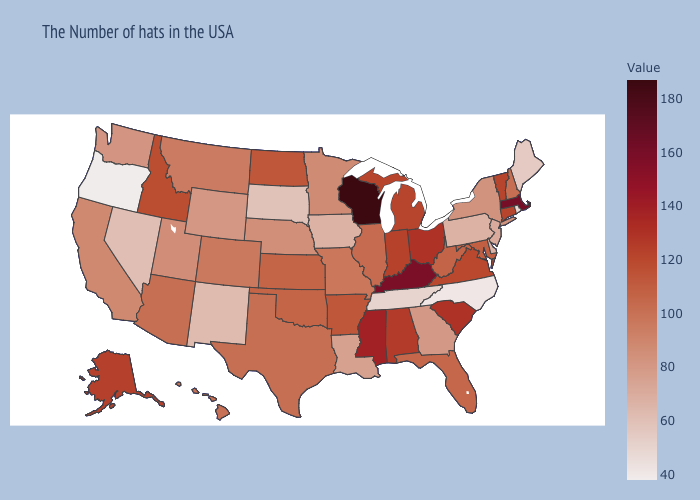Among the states that border Colorado , does New Mexico have the lowest value?
Concise answer only. Yes. Among the states that border North Carolina , does South Carolina have the lowest value?
Concise answer only. No. Does Oregon have a higher value than Maine?
Be succinct. No. Among the states that border West Virginia , does Pennsylvania have the lowest value?
Short answer required. Yes. Which states have the lowest value in the USA?
Short answer required. Oregon. Among the states that border North Dakota , which have the highest value?
Write a very short answer. Montana. 